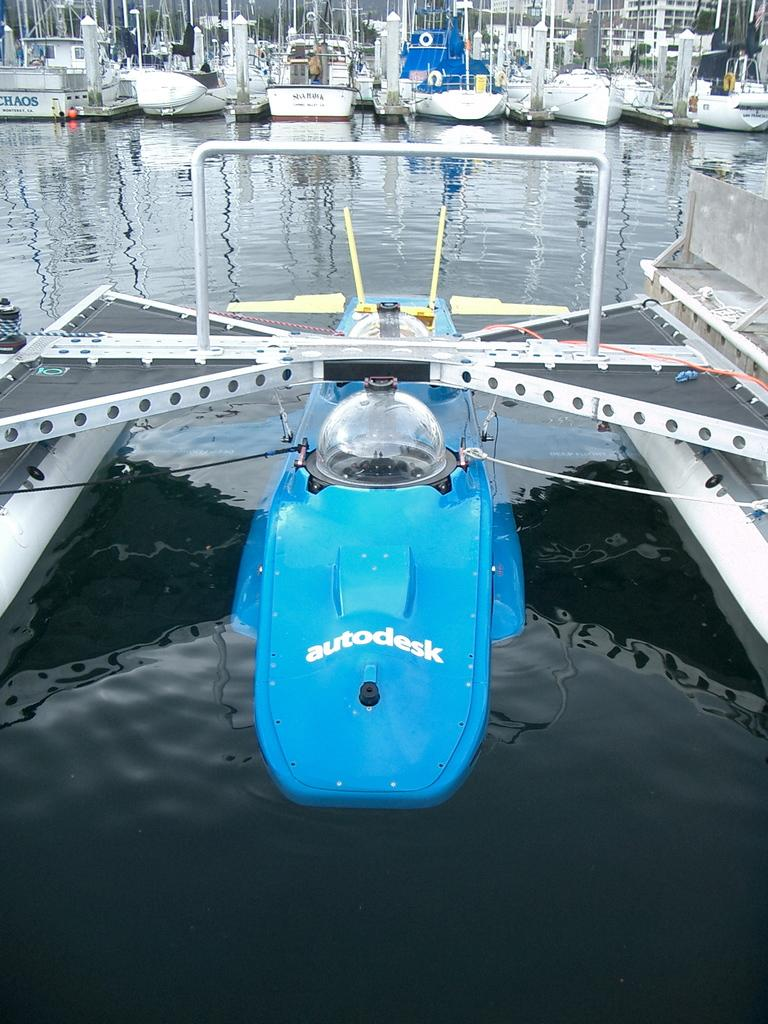Provide a one-sentence caption for the provided image. An autodesk boat that is half in the water and partially docked on the land. 